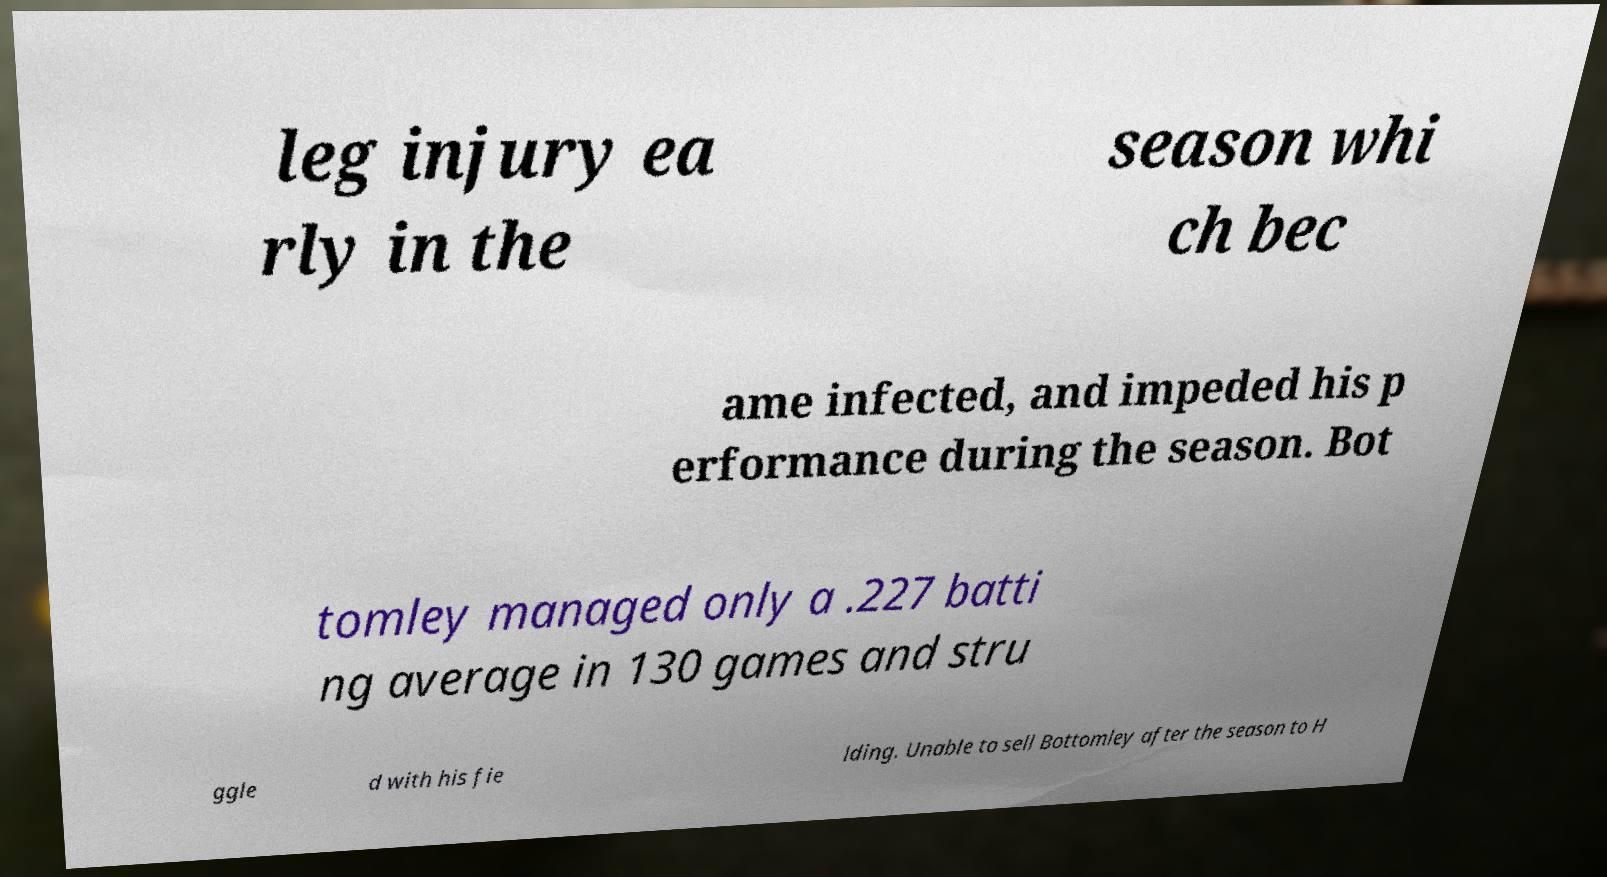Could you extract and type out the text from this image? leg injury ea rly in the season whi ch bec ame infected, and impeded his p erformance during the season. Bot tomley managed only a .227 batti ng average in 130 games and stru ggle d with his fie lding. Unable to sell Bottomley after the season to H 